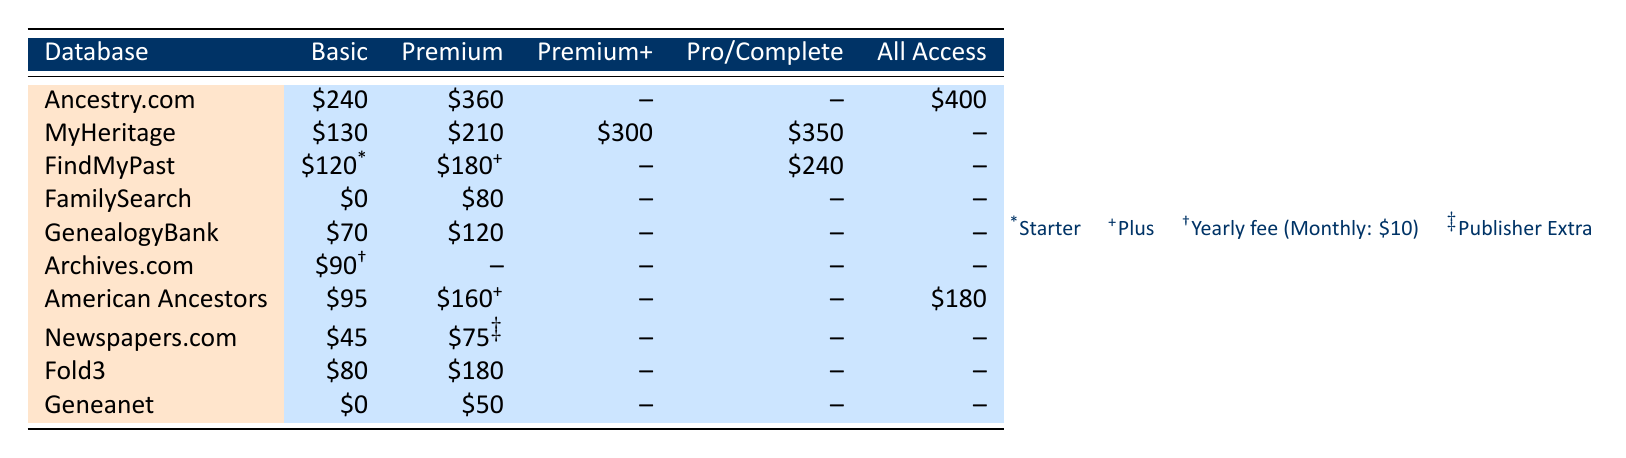What is the membership fee for a Basic membership at Ancestry.com? The table lists the fees for the Basic membership under the Ancestry.com row, which states that the fee is \$240.
Answer: 240 What is the fee difference between the Premium and PremiumPlus memberships for MyHeritage? The Premium membership fee for MyHeritage is \$210, and the PremiumPlus membership fee is \$300. To find the difference, subtract the Premium fee from the PremiumPlus fee: \$300 - \$210 = \$90.
Answer: 90 Does FamilySearch offer a Basic membership fee? According to the table, the fee for the Basic membership at FamilySearch is listed as \$0, which means it is available for free.
Answer: Yes What is the highest membership fee for any database listed in the table? Looking at all the membership fees, Ancestry.com has an All Access membership fee of \$400, which is the highest fee in the table.
Answer: 400 What is the total cost for two consecutive years of a Premium membership at Fold3? The Premium membership fee for Fold3 is \$180 per year. For two years, the total cost would be \( \$180 \times 2 = \$360 \).
Answer: 360 Which database offers the lowest Basic membership fee among all listed? The table shows that Newspapers.com has the lowest Basic membership fee at \$45 when comparing all the Basic fees listed for every database.
Answer: 45 If someone chooses the Complete membership for MyHeritage, how much more would they pay compared to the Basic membership? The Complete membership fee for MyHeritage is \$350 and the Basic membership fee is \$130. The difference is \$350 - \$130 = \$220.
Answer: 220 Is it true that Geneanet has no fee for Basic membership? The table indicates that the Basic membership fee for Geneanet is \$0, confirming that there is indeed no fee.
Answer: True What would be the total membership fee if someone purchases both the Plus membership from FindMyPast and the Premium membership from GenealogyBank? The Plus membership fee for FindMyPast is \$180 and the Premium membership fee for GenealogyBank is \$120. To calculate the total, add both fees together: \$180 + \$120 = \$300.
Answer: 300 